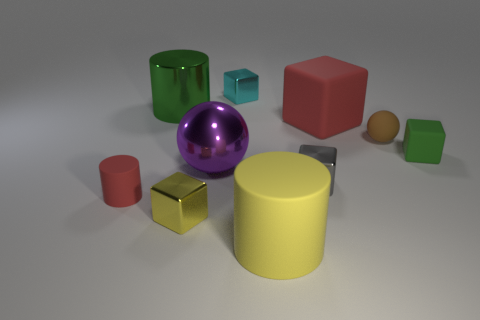There is a object on the left side of the large green object; is it the same shape as the big thing in front of the small red rubber thing?
Keep it short and to the point. Yes. Is there a brown sphere made of the same material as the green block?
Your answer should be very brief. Yes. What color is the large matte thing that is in front of the red cube that is to the right of the green object that is behind the brown matte thing?
Keep it short and to the point. Yellow. Is the material of the sphere in front of the tiny ball the same as the cyan thing that is behind the tiny gray object?
Offer a terse response. Yes. The thing behind the large green cylinder has what shape?
Ensure brevity in your answer.  Cube. What number of objects are gray metallic blocks or small shiny objects to the right of the small cyan shiny block?
Offer a terse response. 1. Do the small brown sphere and the small green object have the same material?
Provide a succinct answer. Yes. Are there the same number of tiny rubber things that are behind the small red rubber cylinder and cylinders behind the yellow cylinder?
Give a very brief answer. Yes. How many tiny green things are behind the big yellow cylinder?
Your answer should be compact. 1. How many things are small yellow metal things or small green rubber blocks?
Your response must be concise. 2. 